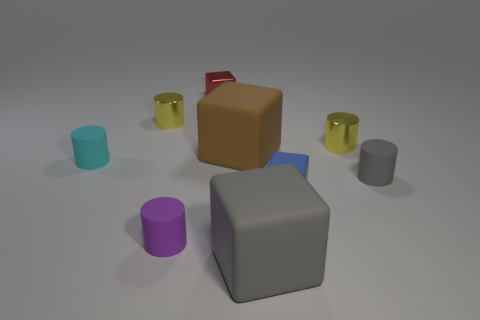Add 1 big gray cubes. How many objects exist? 10 Subtract all cyan cylinders. How many cylinders are left? 4 Subtract all green cubes. How many yellow cylinders are left? 2 Subtract all purple cylinders. How many cylinders are left? 4 Subtract 1 blocks. How many blocks are left? 3 Subtract all cubes. How many objects are left? 5 Subtract all blue cylinders. Subtract all blue cubes. How many cylinders are left? 5 Add 6 blocks. How many blocks are left? 10 Add 7 large matte objects. How many large matte objects exist? 9 Subtract 0 brown balls. How many objects are left? 9 